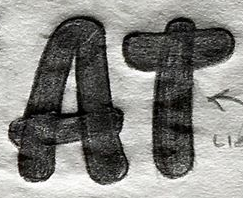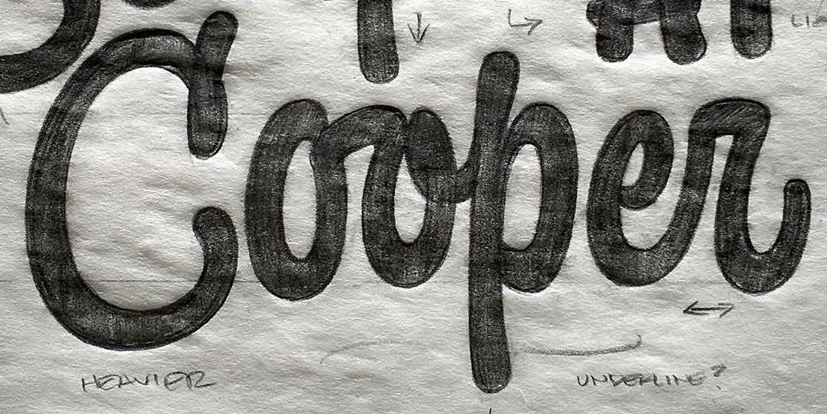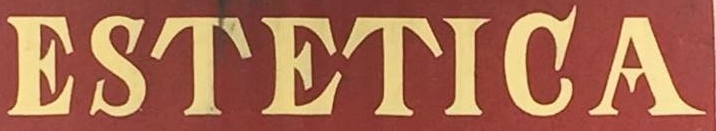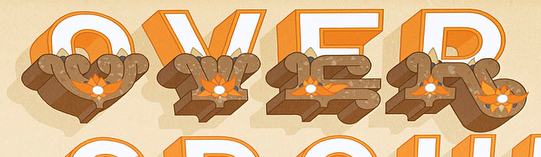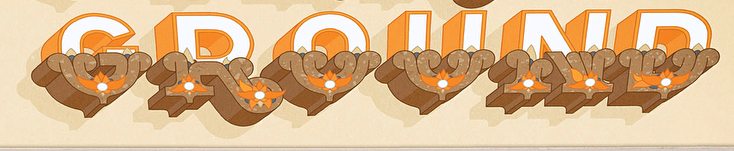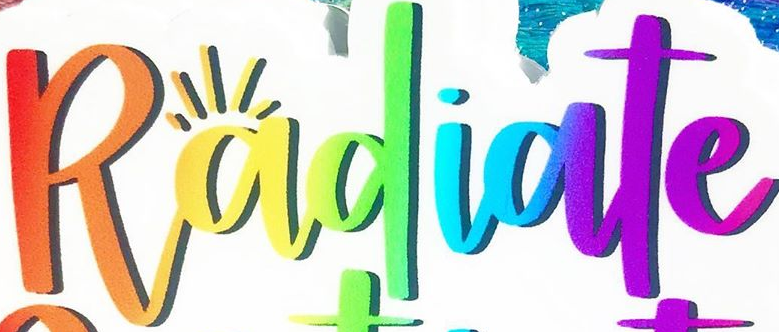What words are shown in these images in order, separated by a semicolon? AT; Corper; ESTETIGA; OVER; GROUND; Radiate 